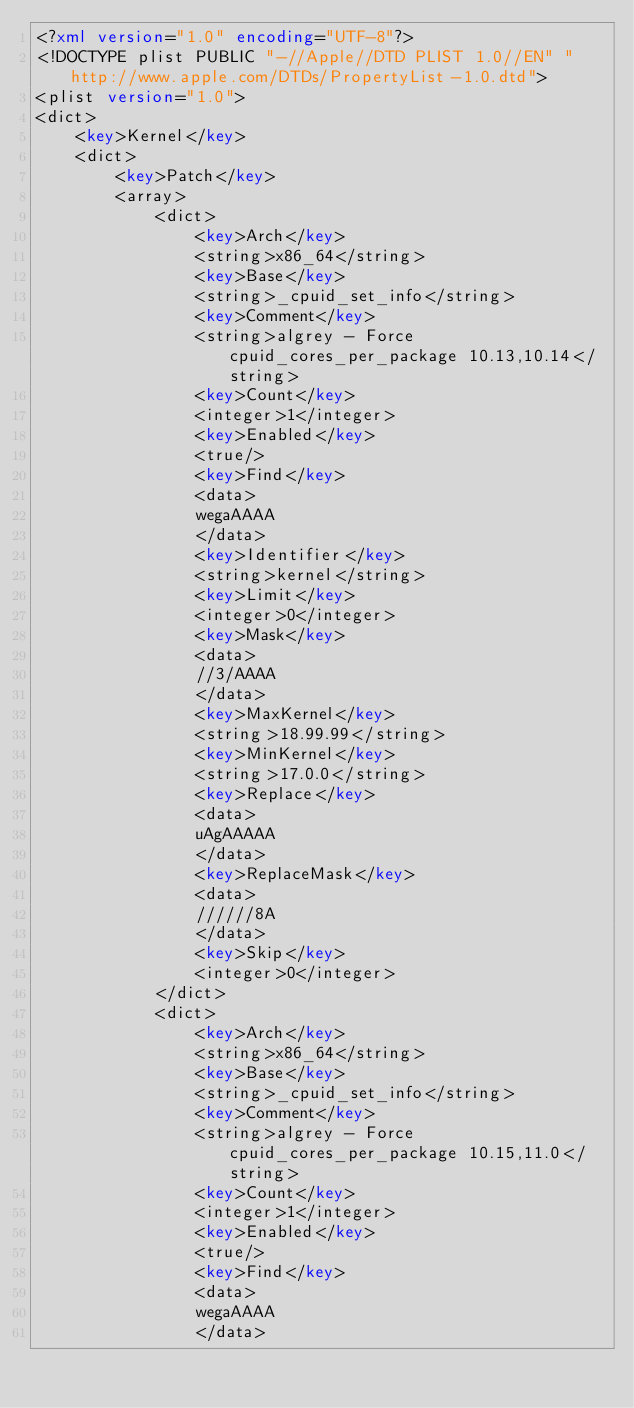Convert code to text. <code><loc_0><loc_0><loc_500><loc_500><_XML_><?xml version="1.0" encoding="UTF-8"?>
<!DOCTYPE plist PUBLIC "-//Apple//DTD PLIST 1.0//EN" "http://www.apple.com/DTDs/PropertyList-1.0.dtd">
<plist version="1.0">
<dict>
	<key>Kernel</key>
	<dict>
		<key>Patch</key>
		<array>
			<dict>
				<key>Arch</key>
				<string>x86_64</string>
				<key>Base</key>
				<string>_cpuid_set_info</string>
				<key>Comment</key>
				<string>algrey - Force cpuid_cores_per_package 10.13,10.14</string>
				<key>Count</key>
				<integer>1</integer>
				<key>Enabled</key>
				<true/>
				<key>Find</key>
				<data>
				wegaAAAA
				</data>
				<key>Identifier</key>
				<string>kernel</string>
				<key>Limit</key>
				<integer>0</integer>
				<key>Mask</key>
				<data>
				//3/AAAA
				</data>
				<key>MaxKernel</key>
				<string>18.99.99</string>
				<key>MinKernel</key>
				<string>17.0.0</string>
				<key>Replace</key>
				<data>
				uAgAAAAA
				</data>
				<key>ReplaceMask</key>
				<data>
				//////8A
				</data>
				<key>Skip</key>
				<integer>0</integer>
			</dict>
			<dict>
				<key>Arch</key>
				<string>x86_64</string>
				<key>Base</key>
				<string>_cpuid_set_info</string>
				<key>Comment</key>
				<string>algrey - Force cpuid_cores_per_package 10.15,11.0</string>
				<key>Count</key>
				<integer>1</integer>
				<key>Enabled</key>
				<true/>
				<key>Find</key>
				<data>
				wegaAAAA
				</data></code> 